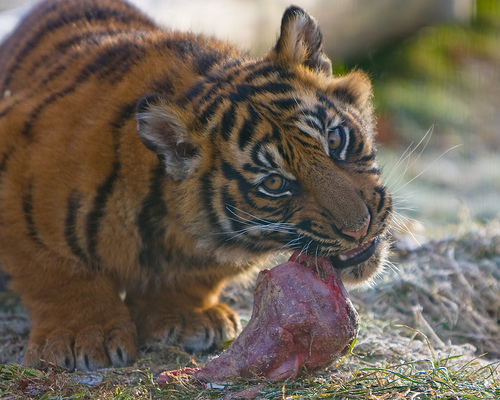<image>
Is the tiger in front of the eating meat? No. The tiger is not in front of the eating meat. The spatial positioning shows a different relationship between these objects. 